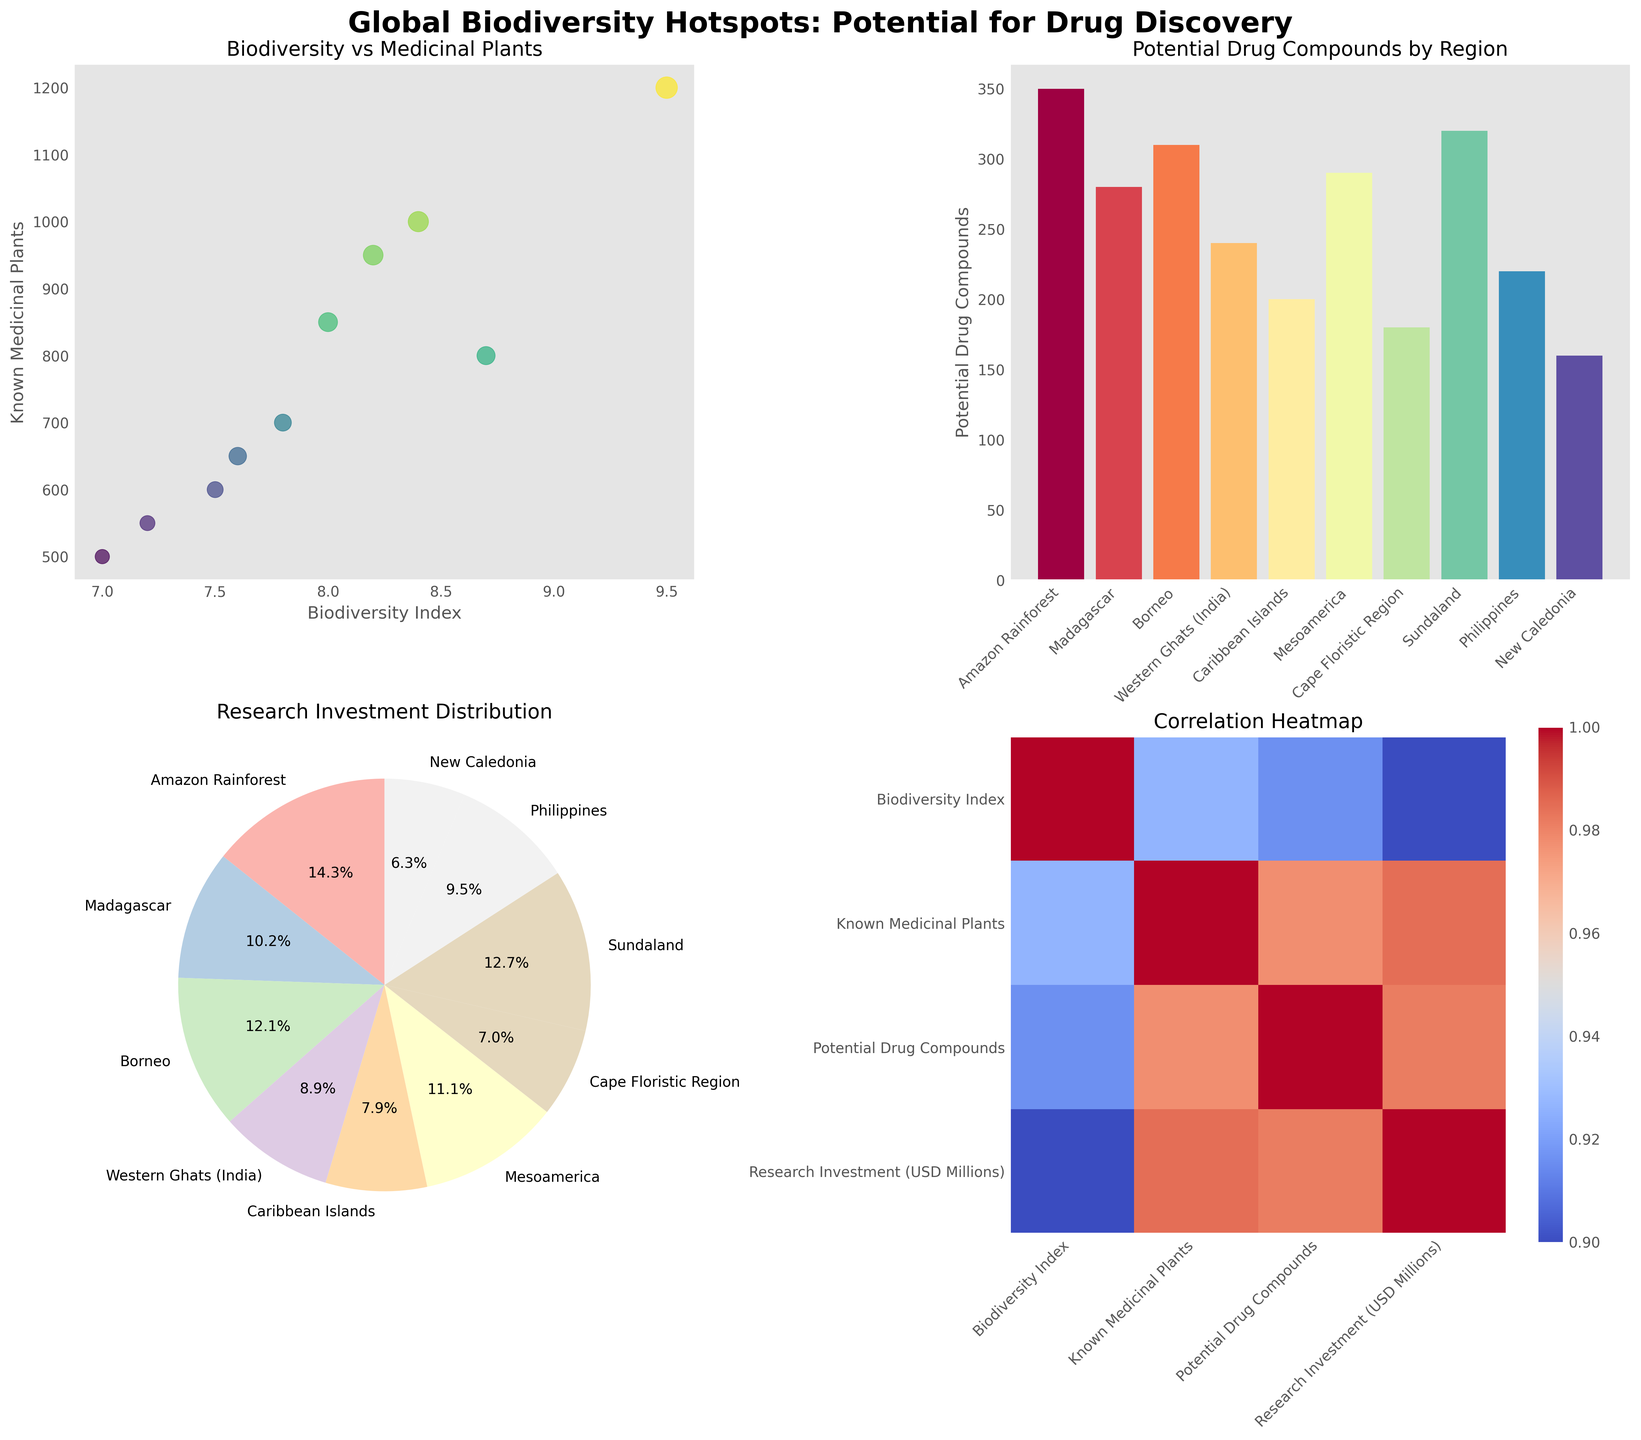Which region has the highest number of potential drug compounds? The bar chart titled "Potential Drug Compounds by Region" shows the number of potential drug compounds for each region. The Amazon Rainforest has the highest bar.
Answer: Amazon Rainforest How is the research investment distributed across regions? The pie chart titled "Research Investment Distribution" shows the share of research investment for each region in percentage.
Answer: Proportional distribution among regions What does the size of the markers represent in the scatter plot? The scatter plot titled "Biodiversity vs Medicinal Plants" indicates that the size of the markers represents research investment, as denoted by the circle sizes in the plot.
Answer: Research investment Which regions have more than 300 known medicinal plants? The scatter plot titled "Biodiversity vs Medicinal Plants" shows the number of known medicinal plants along the y-axis. Regions with marker positions above the 300 mark include Amazon Rainforest, Madagascar, Borneo, and Mesoamerica.
Answer: Amazon Rainforest, Madagascar, Borneo, Mesoamerica Which two regions have the closest number of potential drug compounds? Observing the bar chart "Potential Drug Compounds by Region" reveals that the Western Ghats (India) and Philippines have closely positioned bars, indicating similar counts.
Answer: Western Ghats (India) and Philippines Is there a strong correlation between biodiversity index and known medicinal plants? The heatmap shows correlations between variables. Look at the cell where "Biodiversity Index" and "Known Medicinal Plants" intersect to determine the strength of the correlation. The color indicates a moderate to strong positive correlation.
Answer: Yes What is the title of the overall figure? The large text at the top of the figure denotes the title. It reads "Global Biodiversity Hotspots: Potential for Drug Discovery."
Answer: Global Biodiversity Hotspots: Potential for Drug Discovery Which region has the least amount of research investment? The slice sizes in the pie chart "Research Investment Distribution" indicate the amount of investment. The smallest slice corresponds to New Caledonia.
Answer: New Caledonia How many regions have a biodiversity index of 8 or greater? The scatter plot "Biodiversity vs Medicinal Plants" shows the biodiversity index along the x-axis. Count the number of markers at or above the index 8 line.
Answer: 6 regions What is the relationship between the size and color of the markers in the scatter plot? The scatter plot uses marker size to represent research investment and color gradient (viridis colormap) to reflect potential drug compounds, showing how investment is allocated versus drug discovery potential.
Answer: Size represents research investment, color represents potential drug compounds 